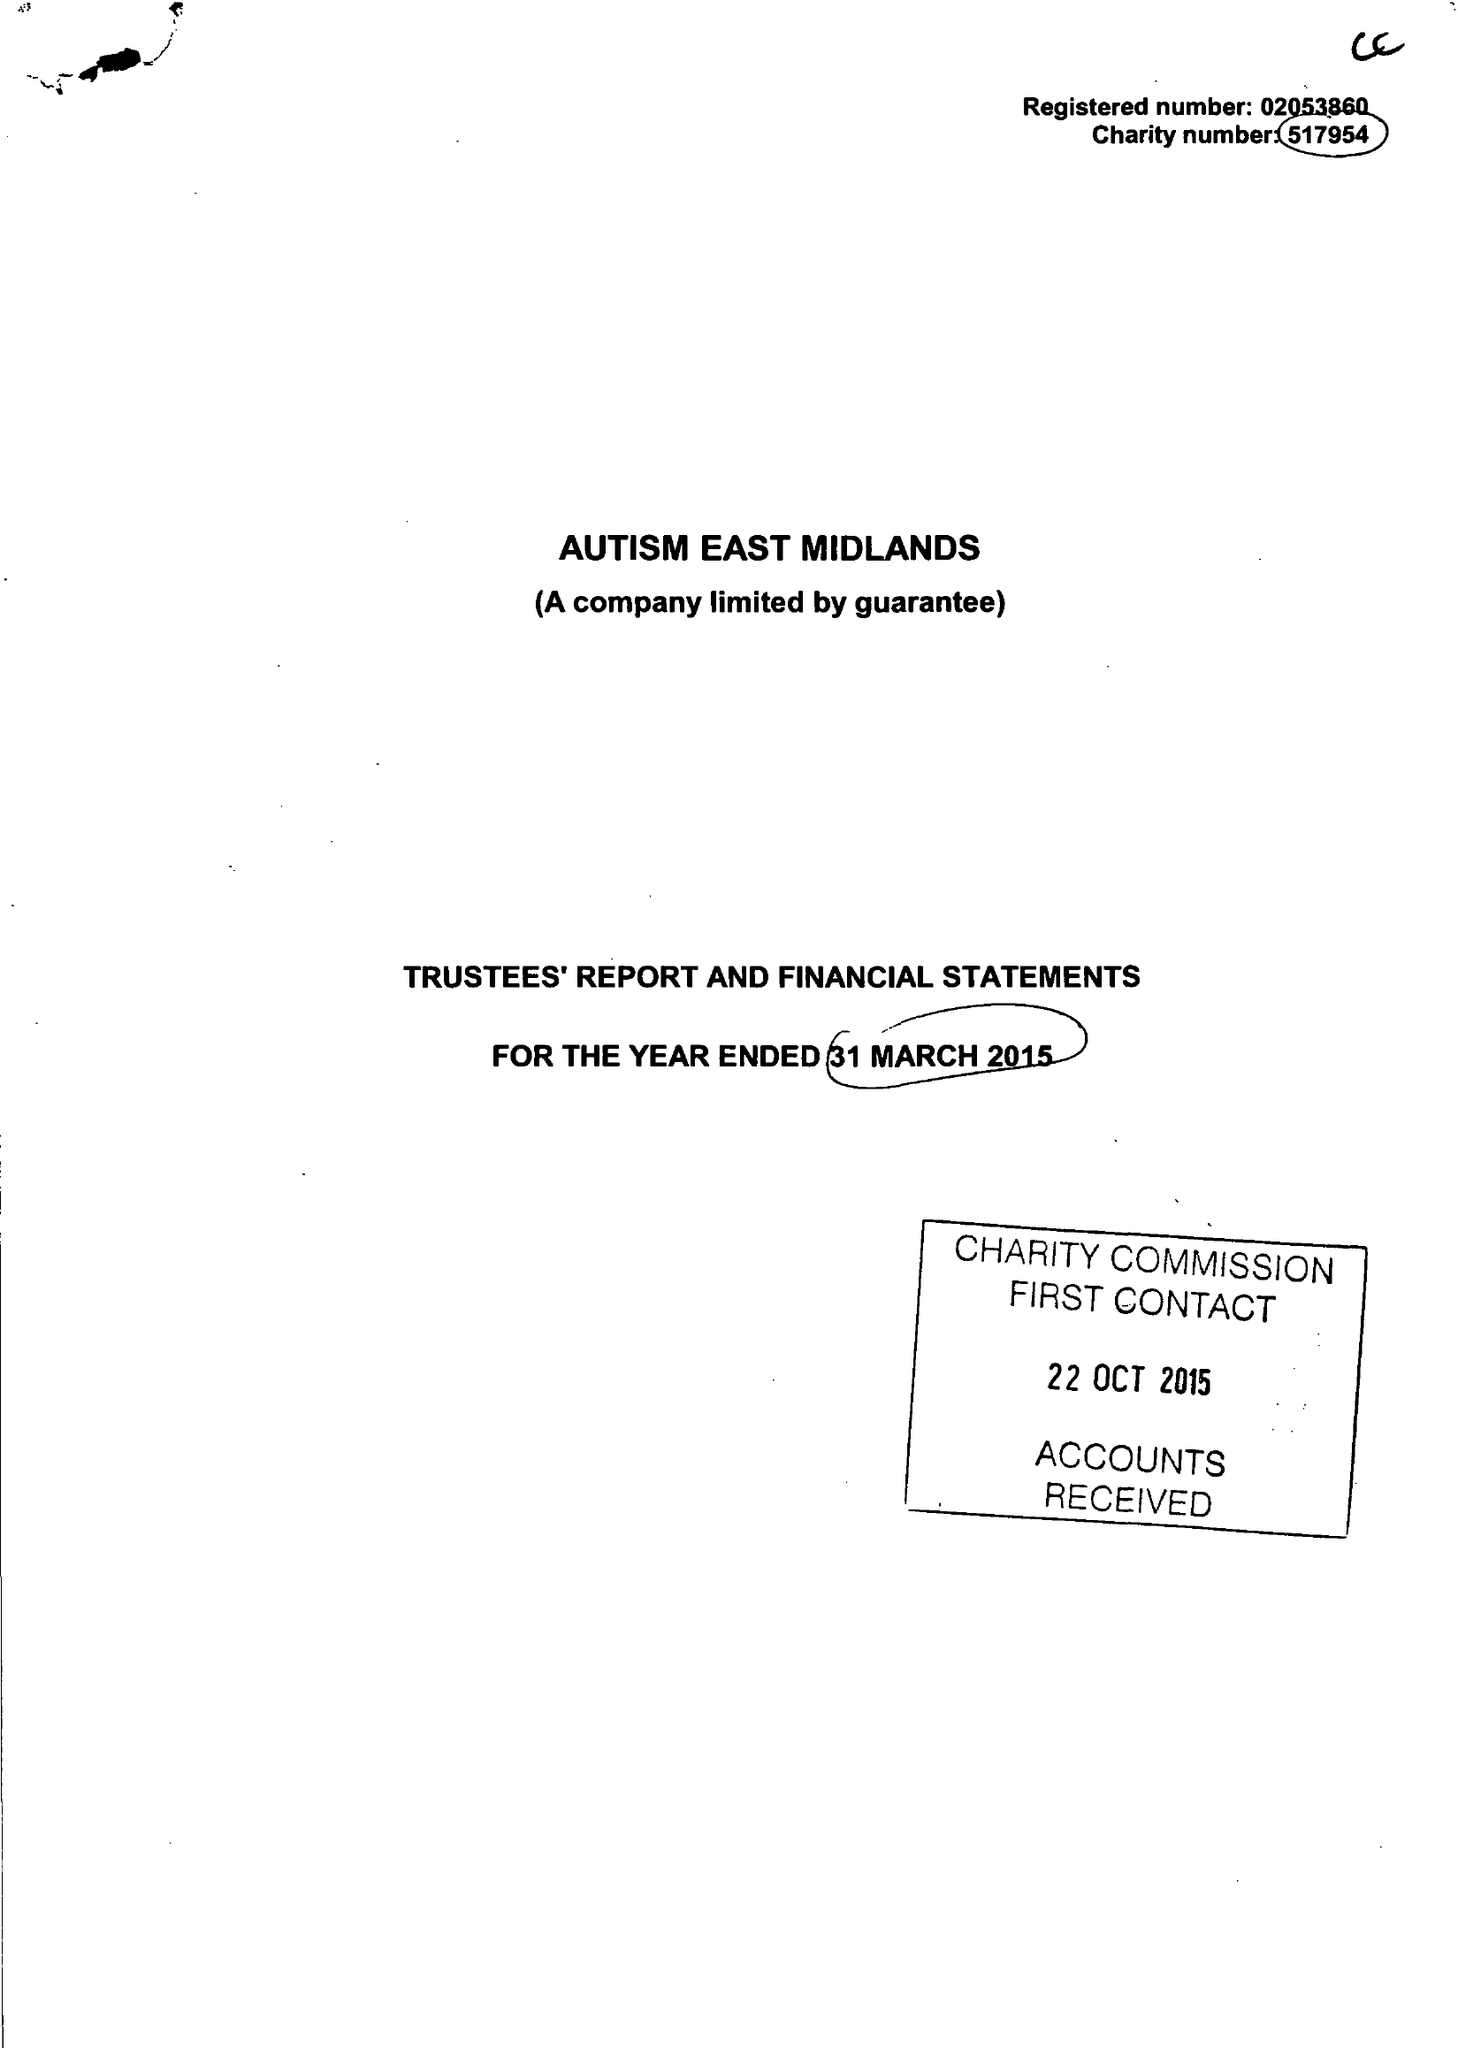What is the value for the address__street_line?
Answer the question using a single word or phrase. MORVEN STREET 